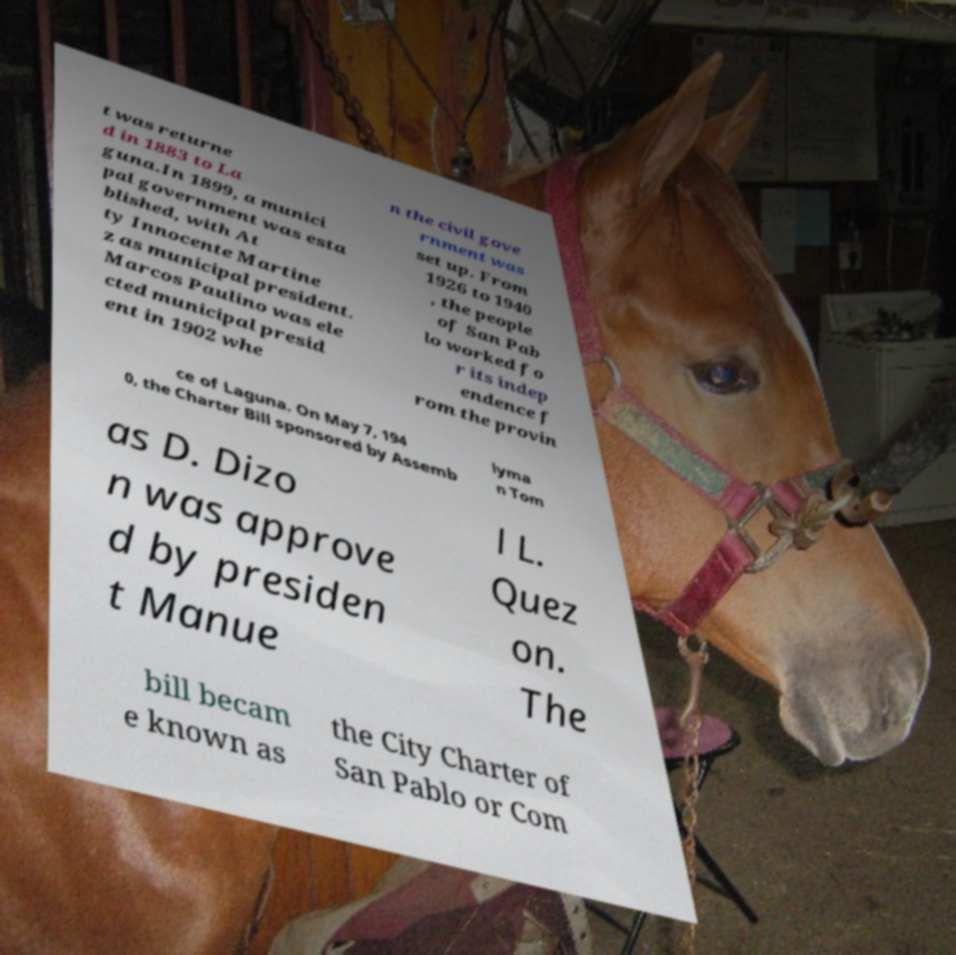Please read and relay the text visible in this image. What does it say? t was returne d in 1883 to La guna.In 1899, a munici pal government was esta blished, with At ty Innocente Martine z as municipal president. Marcos Paulino was ele cted municipal presid ent in 1902 whe n the civil gove rnment was set up. From 1926 to 1940 , the people of San Pab lo worked fo r its indep endence f rom the provin ce of Laguna. On May 7, 194 0, the Charter Bill sponsored by Assemb lyma n Tom as D. Dizo n was approve d by presiden t Manue l L. Quez on. The bill becam e known as the City Charter of San Pablo or Com 